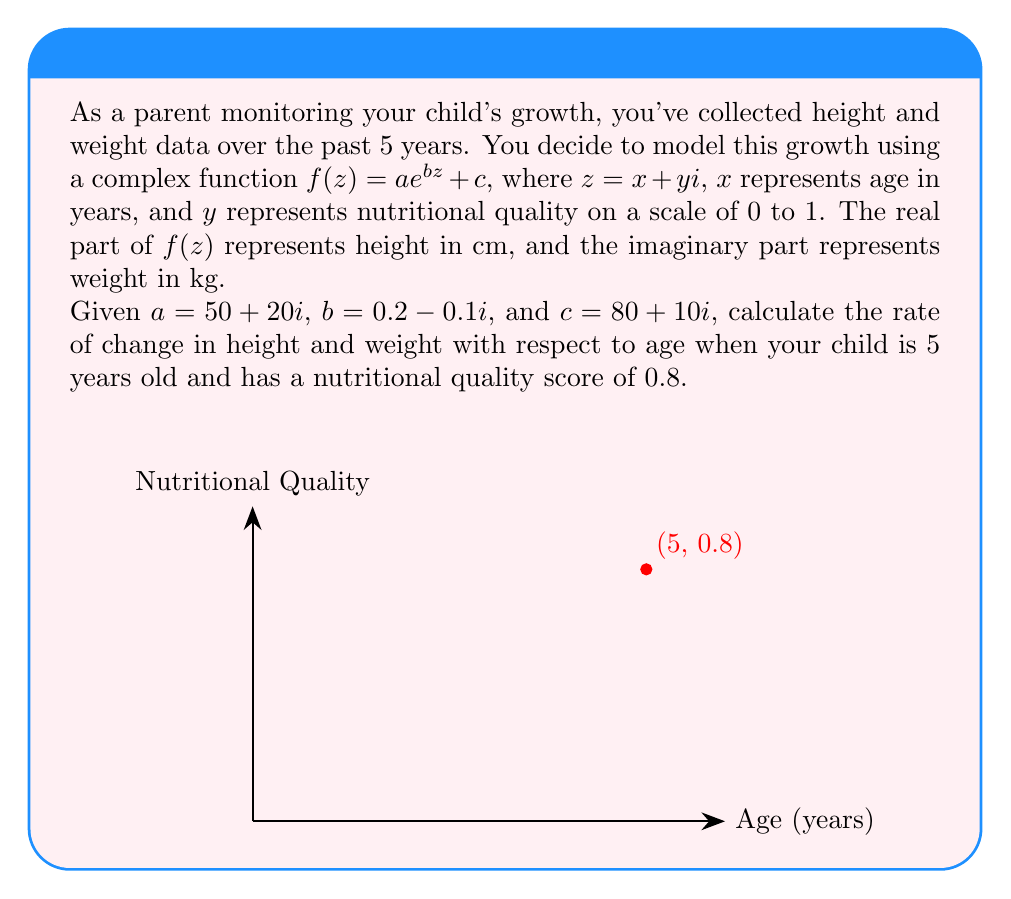Help me with this question. Let's approach this step-by-step:

1) The given function is $f(z) = ae^{bz} + c$, where $z = x + yi$

2) We need to find $\frac{df}{dx}$ at $z = 5 + 0.8i$

3) To do this, we'll use the chain rule: $\frac{df}{dx} = \frac{df}{dz} \cdot \frac{dz}{dx}$

4) First, let's find $\frac{df}{dz}$:
   $\frac{df}{dz} = abe^{bz}$

5) Now, substitute the values:
   $\frac{df}{dz} = (50+20i)(0.2-0.1i)e^{(0.2-0.1i)(5+0.8i)}$

6) Simplify the complex multiplication:
   $(50+20i)(0.2-0.1i) = (10+4i) - (5+2i)i = 10+4i-5i+2 = 12-i$

7) So, $\frac{df}{dz} = (12-i)e^{(0.2-0.1i)(5+0.8i)}$

8) Calculate the exponent:
   $(0.2-0.1i)(5+0.8i) = 1+0.16i-0.5i-0.08i^2 = 1.08+0.66i$

9) Therefore, $\frac{df}{dz} = (12-i)e^{1.08+0.66i}$

10) Now, $\frac{dz}{dx} = 1$ (since $z = x + yi$, and we're differentiating with respect to $x$)

11) So, $\frac{df}{dx} = (12-i)e^{1.08+0.66i}$

12) Evaluate this:
    $e^{1.08+0.66i} = e^{1.08}(\cos(0.66) + i\sin(0.66))$
    $e^{1.08} \approx 2.94$
    $\cos(0.66) \approx 0.79$, $\sin(0.66) \approx 0.61$

13) Multiply:
    $\frac{df}{dx} = (12-i)(2.94(0.79+0.61i))$
    $= (12-i)(2.32+1.79i)$
    $= 27.84+21.48i-2.32+1.79i$
    $= 25.52+23.27i$

14) The real part (25.52) represents the rate of change in height (cm/year), and the imaginary part (23.27) represents the rate of change in weight (kg/year).
Answer: $25.52 + 23.27i$ cm/kg per year 